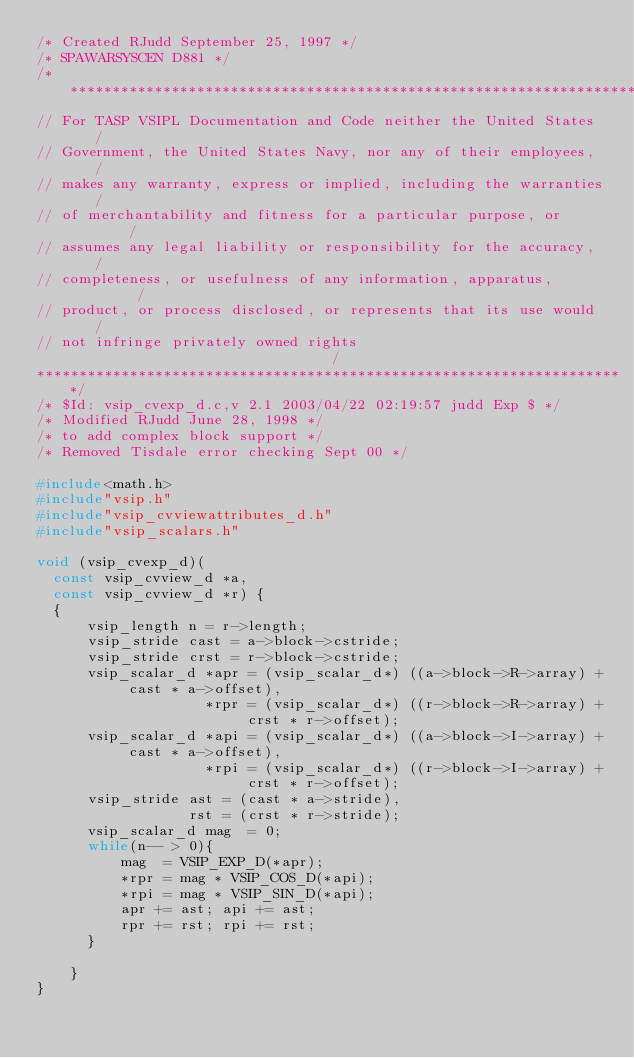<code> <loc_0><loc_0><loc_500><loc_500><_C_>/* Created RJudd September 25, 1997 */
/* SPAWARSYSCEN D881 */
/**********************************************************************
// For TASP VSIPL Documentation and Code neither the United States    /
// Government, the United States Navy, nor any of their employees,    /
// makes any warranty, express or implied, including the warranties   /
// of merchantability and fitness for a particular purpose, or        /
// assumes any legal liability or responsibility for the accuracy,    /
// completeness, or usefulness of any information, apparatus,         /
// product, or process disclosed, or represents that its use would    /
// not infringe privately owned rights                                /
**********************************************************************/
/* $Id: vsip_cvexp_d.c,v 2.1 2003/04/22 02:19:57 judd Exp $ */
/* Modified RJudd June 28, 1998 */
/* to add complex block support */
/* Removed Tisdale error checking Sept 00 */

#include<math.h>
#include"vsip.h"
#include"vsip_cvviewattributes_d.h"
#include"vsip_scalars.h"

void (vsip_cvexp_d)(
  const vsip_cvview_d *a,
  const vsip_cvview_d *r) {
  {
      vsip_length n = r->length;
      vsip_stride cast = a->block->cstride;
      vsip_stride crst = r->block->cstride;
      vsip_scalar_d *apr = (vsip_scalar_d*) ((a->block->R->array) + cast * a->offset),
                    *rpr = (vsip_scalar_d*) ((r->block->R->array) + crst * r->offset);
      vsip_scalar_d *api = (vsip_scalar_d*) ((a->block->I->array) + cast * a->offset),
                    *rpi = (vsip_scalar_d*) ((r->block->I->array) + crst * r->offset);
      vsip_stride ast = (cast * a->stride),
                  rst = (crst * r->stride);
      vsip_scalar_d mag  = 0;
      while(n-- > 0){
          mag  = VSIP_EXP_D(*apr);
          *rpr = mag * VSIP_COS_D(*api);
          *rpi = mag * VSIP_SIN_D(*api);
          apr += ast; api += ast; 
          rpr += rst; rpi += rst;
      }

    }
}
</code> 